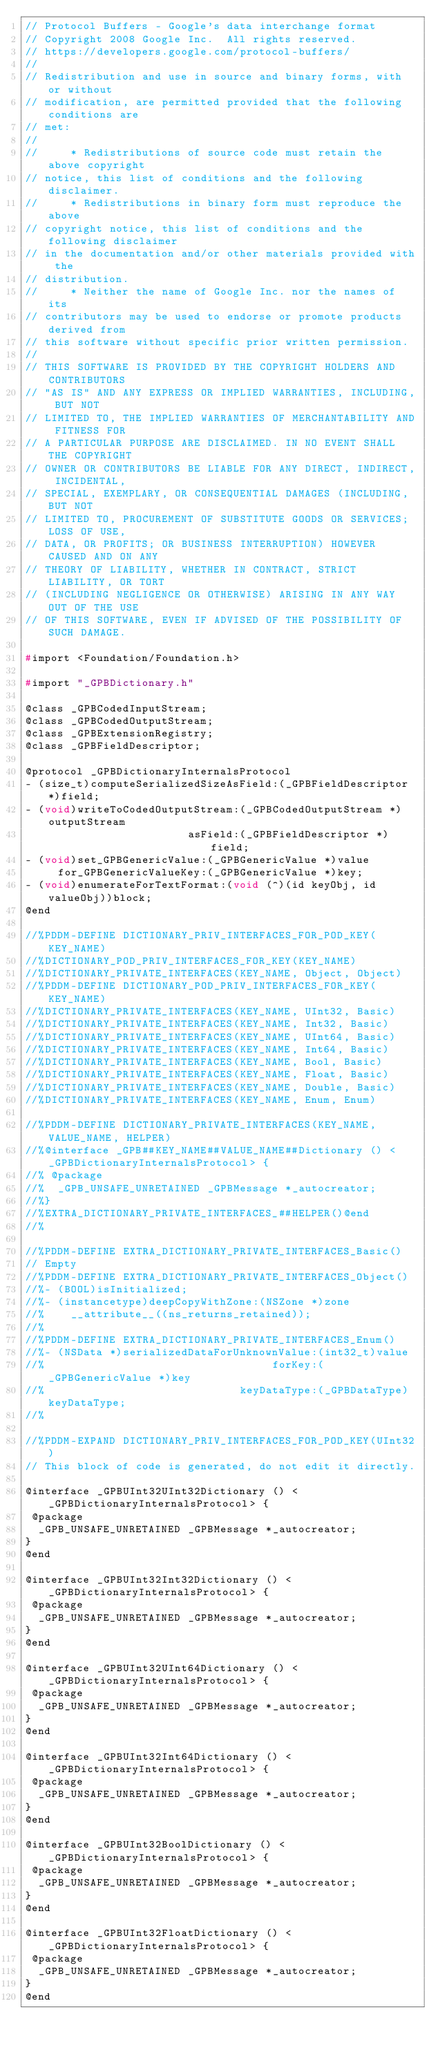<code> <loc_0><loc_0><loc_500><loc_500><_C_>// Protocol Buffers - Google's data interchange format
// Copyright 2008 Google Inc.  All rights reserved.
// https://developers.google.com/protocol-buffers/
//
// Redistribution and use in source and binary forms, with or without
// modification, are permitted provided that the following conditions are
// met:
//
//     * Redistributions of source code must retain the above copyright
// notice, this list of conditions and the following disclaimer.
//     * Redistributions in binary form must reproduce the above
// copyright notice, this list of conditions and the following disclaimer
// in the documentation and/or other materials provided with the
// distribution.
//     * Neither the name of Google Inc. nor the names of its
// contributors may be used to endorse or promote products derived from
// this software without specific prior written permission.
//
// THIS SOFTWARE IS PROVIDED BY THE COPYRIGHT HOLDERS AND CONTRIBUTORS
// "AS IS" AND ANY EXPRESS OR IMPLIED WARRANTIES, INCLUDING, BUT NOT
// LIMITED TO, THE IMPLIED WARRANTIES OF MERCHANTABILITY AND FITNESS FOR
// A PARTICULAR PURPOSE ARE DISCLAIMED. IN NO EVENT SHALL THE COPYRIGHT
// OWNER OR CONTRIBUTORS BE LIABLE FOR ANY DIRECT, INDIRECT, INCIDENTAL,
// SPECIAL, EXEMPLARY, OR CONSEQUENTIAL DAMAGES (INCLUDING, BUT NOT
// LIMITED TO, PROCUREMENT OF SUBSTITUTE GOODS OR SERVICES; LOSS OF USE,
// DATA, OR PROFITS; OR BUSINESS INTERRUPTION) HOWEVER CAUSED AND ON ANY
// THEORY OF LIABILITY, WHETHER IN CONTRACT, STRICT LIABILITY, OR TORT
// (INCLUDING NEGLIGENCE OR OTHERWISE) ARISING IN ANY WAY OUT OF THE USE
// OF THIS SOFTWARE, EVEN IF ADVISED OF THE POSSIBILITY OF SUCH DAMAGE.

#import <Foundation/Foundation.h>

#import "_GPBDictionary.h"

@class _GPBCodedInputStream;
@class _GPBCodedOutputStream;
@class _GPBExtensionRegistry;
@class _GPBFieldDescriptor;

@protocol _GPBDictionaryInternalsProtocol
- (size_t)computeSerializedSizeAsField:(_GPBFieldDescriptor *)field;
- (void)writeToCodedOutputStream:(_GPBCodedOutputStream *)outputStream
                         asField:(_GPBFieldDescriptor *)field;
- (void)set_GPBGenericValue:(_GPBGenericValue *)value
     for_GPBGenericValueKey:(_GPBGenericValue *)key;
- (void)enumerateForTextFormat:(void (^)(id keyObj, id valueObj))block;
@end

//%PDDM-DEFINE DICTIONARY_PRIV_INTERFACES_FOR_POD_KEY(KEY_NAME)
//%DICTIONARY_POD_PRIV_INTERFACES_FOR_KEY(KEY_NAME)
//%DICTIONARY_PRIVATE_INTERFACES(KEY_NAME, Object, Object)
//%PDDM-DEFINE DICTIONARY_POD_PRIV_INTERFACES_FOR_KEY(KEY_NAME)
//%DICTIONARY_PRIVATE_INTERFACES(KEY_NAME, UInt32, Basic)
//%DICTIONARY_PRIVATE_INTERFACES(KEY_NAME, Int32, Basic)
//%DICTIONARY_PRIVATE_INTERFACES(KEY_NAME, UInt64, Basic)
//%DICTIONARY_PRIVATE_INTERFACES(KEY_NAME, Int64, Basic)
//%DICTIONARY_PRIVATE_INTERFACES(KEY_NAME, Bool, Basic)
//%DICTIONARY_PRIVATE_INTERFACES(KEY_NAME, Float, Basic)
//%DICTIONARY_PRIVATE_INTERFACES(KEY_NAME, Double, Basic)
//%DICTIONARY_PRIVATE_INTERFACES(KEY_NAME, Enum, Enum)

//%PDDM-DEFINE DICTIONARY_PRIVATE_INTERFACES(KEY_NAME, VALUE_NAME, HELPER)
//%@interface _GPB##KEY_NAME##VALUE_NAME##Dictionary () <_GPBDictionaryInternalsProtocol> {
//% @package
//%  _GPB_UNSAFE_UNRETAINED _GPBMessage *_autocreator;
//%}
//%EXTRA_DICTIONARY_PRIVATE_INTERFACES_##HELPER()@end
//%

//%PDDM-DEFINE EXTRA_DICTIONARY_PRIVATE_INTERFACES_Basic()
// Empty
//%PDDM-DEFINE EXTRA_DICTIONARY_PRIVATE_INTERFACES_Object()
//%- (BOOL)isInitialized;
//%- (instancetype)deepCopyWithZone:(NSZone *)zone
//%    __attribute__((ns_returns_retained));
//%
//%PDDM-DEFINE EXTRA_DICTIONARY_PRIVATE_INTERFACES_Enum()
//%- (NSData *)serializedDataForUnknownValue:(int32_t)value
//%                                   forKey:(_GPBGenericValue *)key
//%                              keyDataType:(_GPBDataType)keyDataType;
//%

//%PDDM-EXPAND DICTIONARY_PRIV_INTERFACES_FOR_POD_KEY(UInt32)
// This block of code is generated, do not edit it directly.

@interface _GPBUInt32UInt32Dictionary () <_GPBDictionaryInternalsProtocol> {
 @package
  _GPB_UNSAFE_UNRETAINED _GPBMessage *_autocreator;
}
@end

@interface _GPBUInt32Int32Dictionary () <_GPBDictionaryInternalsProtocol> {
 @package
  _GPB_UNSAFE_UNRETAINED _GPBMessage *_autocreator;
}
@end

@interface _GPBUInt32UInt64Dictionary () <_GPBDictionaryInternalsProtocol> {
 @package
  _GPB_UNSAFE_UNRETAINED _GPBMessage *_autocreator;
}
@end

@interface _GPBUInt32Int64Dictionary () <_GPBDictionaryInternalsProtocol> {
 @package
  _GPB_UNSAFE_UNRETAINED _GPBMessage *_autocreator;
}
@end

@interface _GPBUInt32BoolDictionary () <_GPBDictionaryInternalsProtocol> {
 @package
  _GPB_UNSAFE_UNRETAINED _GPBMessage *_autocreator;
}
@end

@interface _GPBUInt32FloatDictionary () <_GPBDictionaryInternalsProtocol> {
 @package
  _GPB_UNSAFE_UNRETAINED _GPBMessage *_autocreator;
}
@end
</code> 